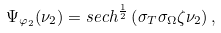Convert formula to latex. <formula><loc_0><loc_0><loc_500><loc_500>\Psi _ { \varphi _ { 2 } } ( \nu _ { 2 } ) = s e c h ^ { \frac { 1 } { 2 } } \left ( \sigma _ { T } \sigma _ { \Omega } \zeta \nu _ { 2 } \right ) ,</formula> 